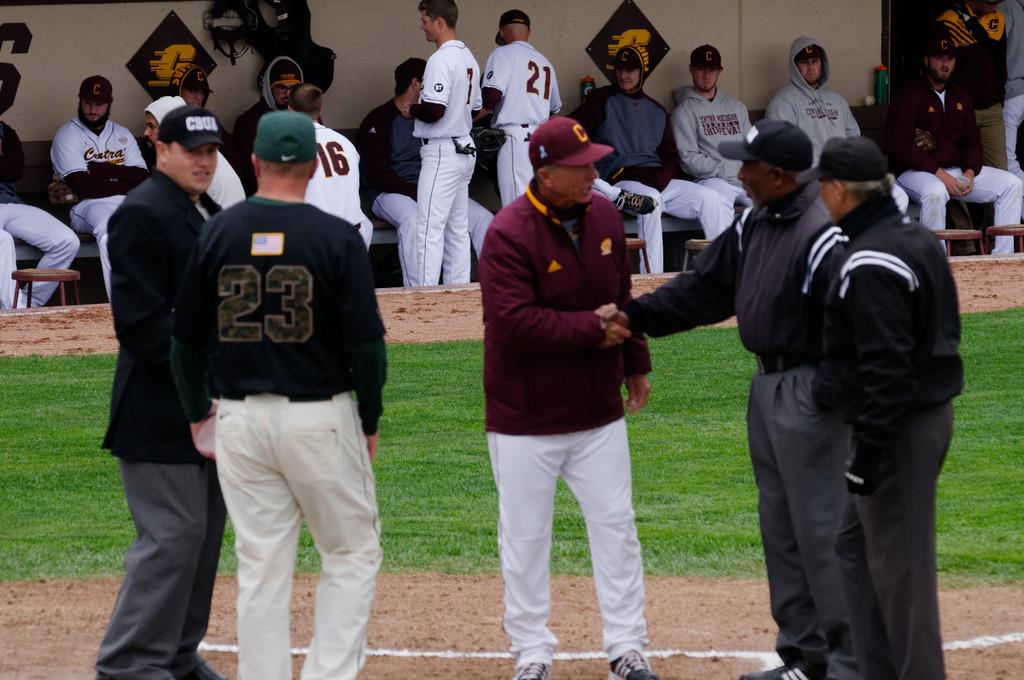What is the player number in the black sweater?
Your response must be concise. 23. 